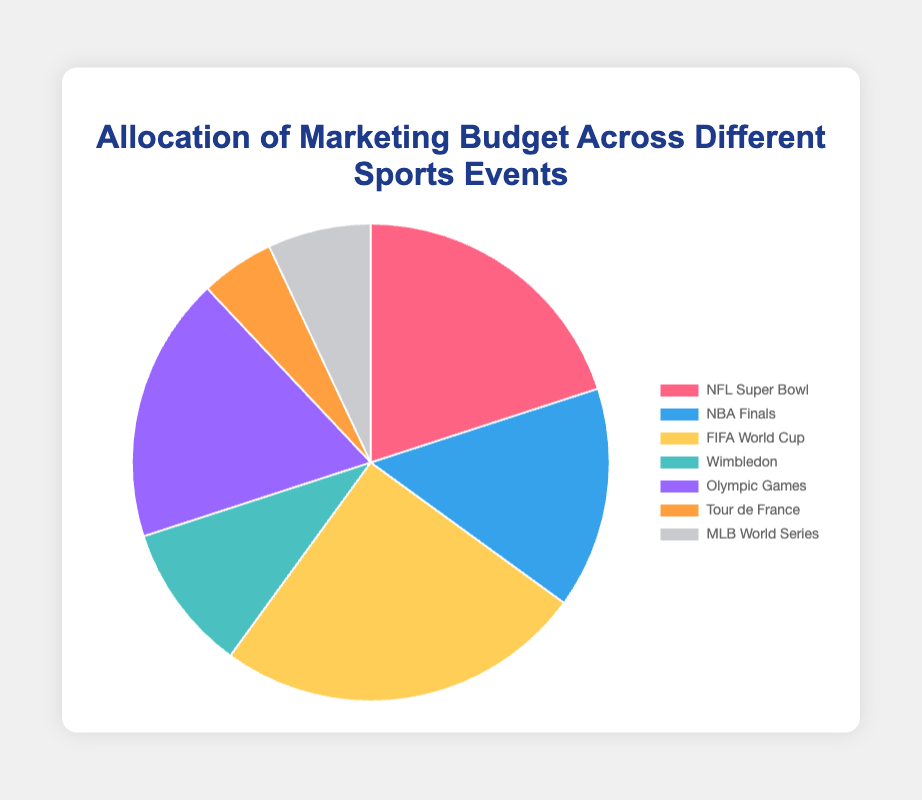Which event has been allocated the highest percentage of the marketing budget? The FIFA World Cup has been allocated 25% of the marketing budget, which is the highest among all events.
Answer: FIFA World Cup Which event has the smallest slice in the pie chart? The Tour de France has the smallest allocation with only 5% of the marketing budget.
Answer: Tour de France What is the total percentage of the marketing budget allocated to the NFL Super Bowl and the NBA Finals combined? The NFL Super Bowl is allocated 20% and the NBA Finals 15%. Combined, they total 20% + 15% = 35%.
Answer: 35% How does the Olympic Games' budget allocation compare to Wimbledon? The Olympic Games have an allocation of 18%, while Wimbledon has 10%. Thus, the Olympic Games have been allocated 8% more.
Answer: 8% more Which event has the second highest allocation in the marketing budget, and what is that percentage? The NFL Super Bowl has the second highest allocation with 20% of the marketing budget.
Answer: NFL Super Bowl, 20% What percentage of the marketing budget is allocated to events other than the FIFA World Cup and the NFL Super Bowl combined? The total percentage for all events is 100%. Subtracting the FIFA World Cup (25%) and the NFL Super Bowl (20%) gives 100% - 25% - 20% = 55%.
Answer: 55% Which events have been allocated more than 15% of the marketing budget? The FIFA World Cup at 25%, the NFL Super Bowl at 20%, and the Olympic Games at 18% are all allocated more than 15%.
Answer: FIFA World Cup, NFL Super Bowl, Olympic Games How does the allocation for the MLB World Series (7%) compare visually to the Tour de France (5%)? Visually, the slice for the MLB World Series is slightly larger than the Tour de France, reflecting the difference in budget allocation (7% versus 5%).
Answer: Slightly larger Is the total allocation for Wimbledon, Tour de France, and MLB World Series less than 50% of the marketing budget? Wimbledon is 10%, Tour de France is 5%, and MLB World Series is 7%. Their total is 10% + 5% + 7% = 22%, which is indeed less than 50%.
Answer: Yes, 22% What percentage allocation is represented by the light blue color section? The light blue section in the pie chart represents the NBA Finals, which have been allocated 15% of the marketing budget.
Answer: 15% 